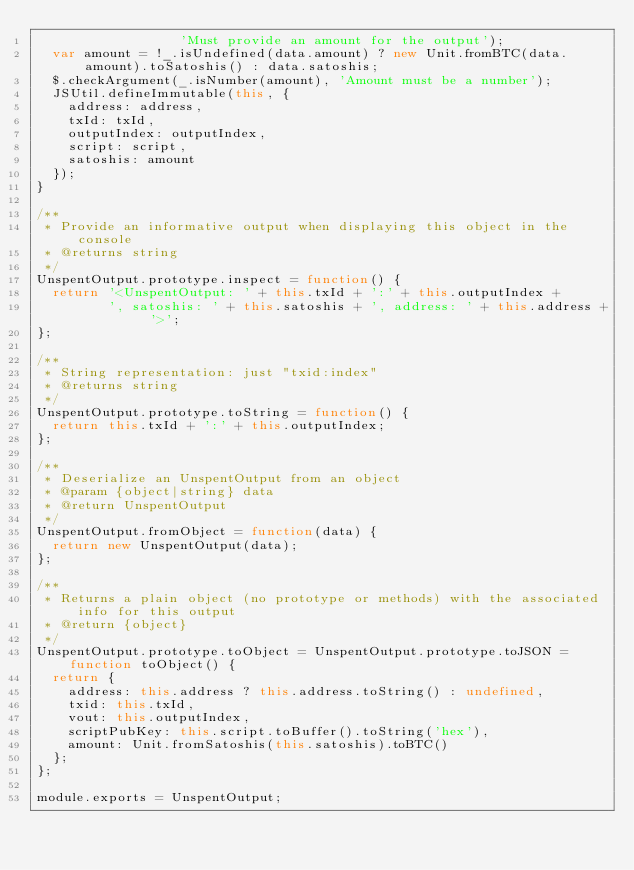Convert code to text. <code><loc_0><loc_0><loc_500><loc_500><_JavaScript_>                  'Must provide an amount for the output');
  var amount = !_.isUndefined(data.amount) ? new Unit.fromBTC(data.amount).toSatoshis() : data.satoshis;
  $.checkArgument(_.isNumber(amount), 'Amount must be a number');
  JSUtil.defineImmutable(this, {
    address: address,
    txId: txId,
    outputIndex: outputIndex,
    script: script,
    satoshis: amount
  });
}

/**
 * Provide an informative output when displaying this object in the console
 * @returns string
 */
UnspentOutput.prototype.inspect = function() {
  return '<UnspentOutput: ' + this.txId + ':' + this.outputIndex +
         ', satoshis: ' + this.satoshis + ', address: ' + this.address + '>';
};

/**
 * String representation: just "txid:index"
 * @returns string
 */
UnspentOutput.prototype.toString = function() {
  return this.txId + ':' + this.outputIndex;
};

/**
 * Deserialize an UnspentOutput from an object
 * @param {object|string} data
 * @return UnspentOutput
 */
UnspentOutput.fromObject = function(data) {
  return new UnspentOutput(data);
};

/**
 * Returns a plain object (no prototype or methods) with the associated info for this output
 * @return {object}
 */
UnspentOutput.prototype.toObject = UnspentOutput.prototype.toJSON = function toObject() {
  return {
    address: this.address ? this.address.toString() : undefined,
    txid: this.txId,
    vout: this.outputIndex,
    scriptPubKey: this.script.toBuffer().toString('hex'),
    amount: Unit.fromSatoshis(this.satoshis).toBTC()
  };
};

module.exports = UnspentOutput;
</code> 